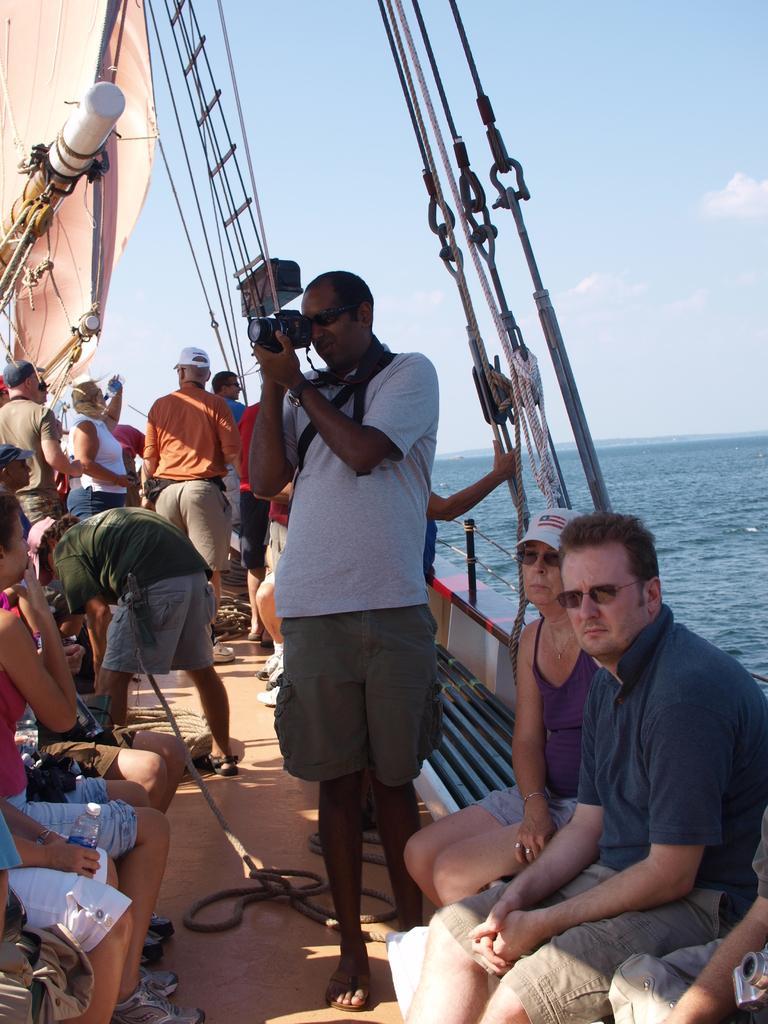Could you give a brief overview of what you see in this image? In this image there are few people travelling on a ship, which is on the river, one of them is holding a camera in his hand. In the background there is a sky. 